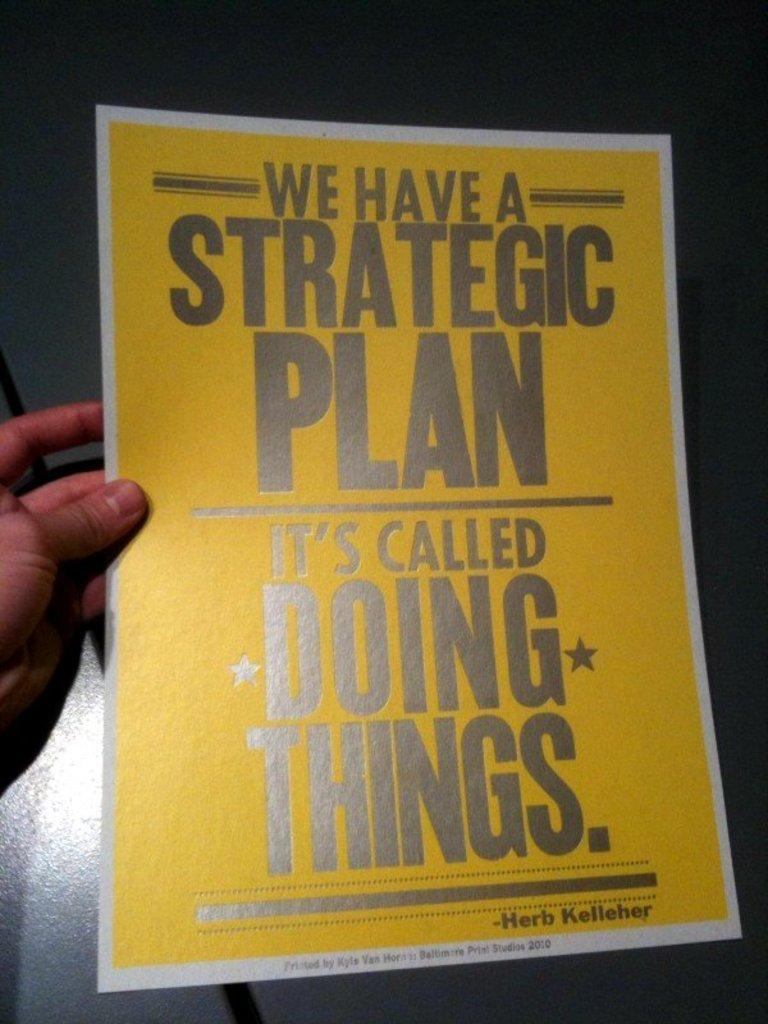<image>
Offer a succinct explanation of the picture presented. A poster with a quote by Herb Kelleher on it. 